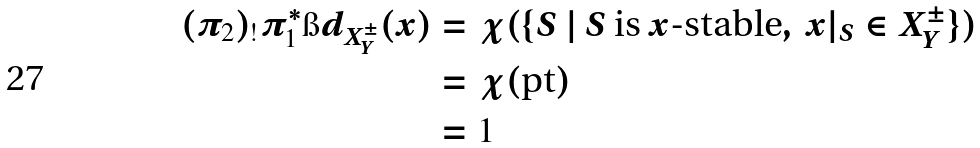<formula> <loc_0><loc_0><loc_500><loc_500>( \pi _ { 2 } ) _ { ! } \pi _ { 1 } ^ { * } \i d _ { X ^ { \pm } _ { Y } } ( x ) & = \chi ( \{ S \ | \ S \text { is $x$-stable} , \ x | _ { S } \in X ^ { \pm } _ { Y } \} ) \\ & = \chi ( \text {pt} ) \\ & = 1</formula> 